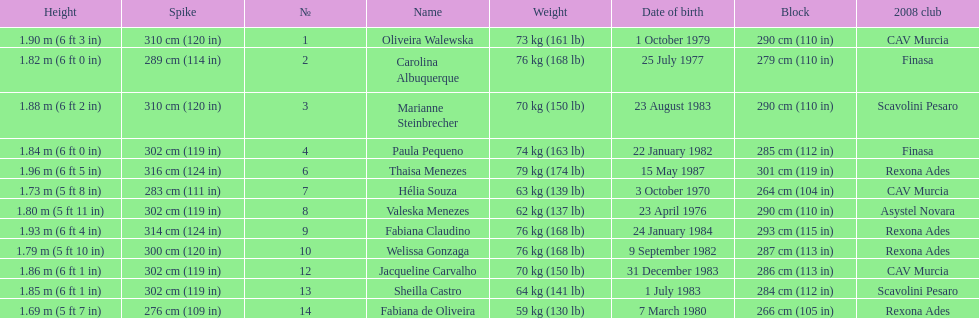Whose weight is the heaviest among the following: fabiana de oliveira, helia souza, or sheilla castro? Sheilla Castro. 